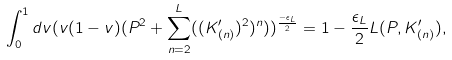Convert formula to latex. <formula><loc_0><loc_0><loc_500><loc_500>\int _ { 0 } ^ { 1 } d v ( v ( 1 - v ) ( P ^ { 2 } + \sum _ { n = 2 } ^ { L } ( ( K ^ { \prime } _ { ( n ) } ) ^ { 2 } ) ^ { n } ) ) ^ { \frac { - \epsilon _ { L } } { 2 } } = 1 - \frac { \epsilon _ { L } } { 2 } L ( P , K ^ { \prime } _ { ( n ) } ) ,</formula> 